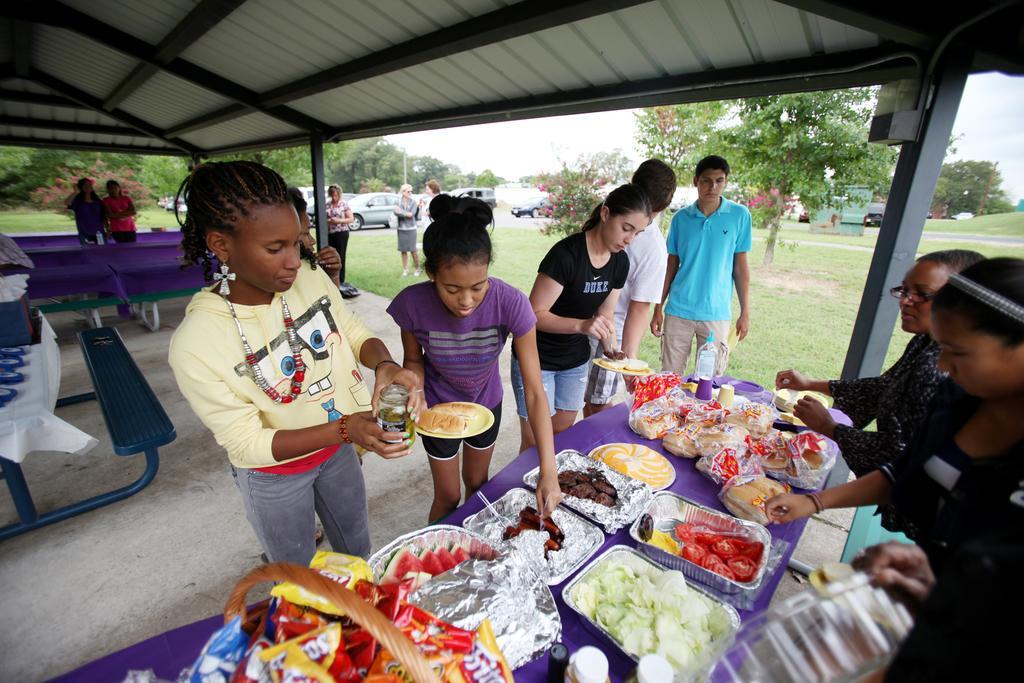In one or two sentences, can you explain what this image depicts? In this picture we can see there are groups of people standing. In front of the people there is a table and on the table there is a basket, cups, bottle, a plate and some food items. On the left side of the people there is a bench. Behind the bench, there are some objects. Behind the people there are trees, some vehicles on the road and the sky. 